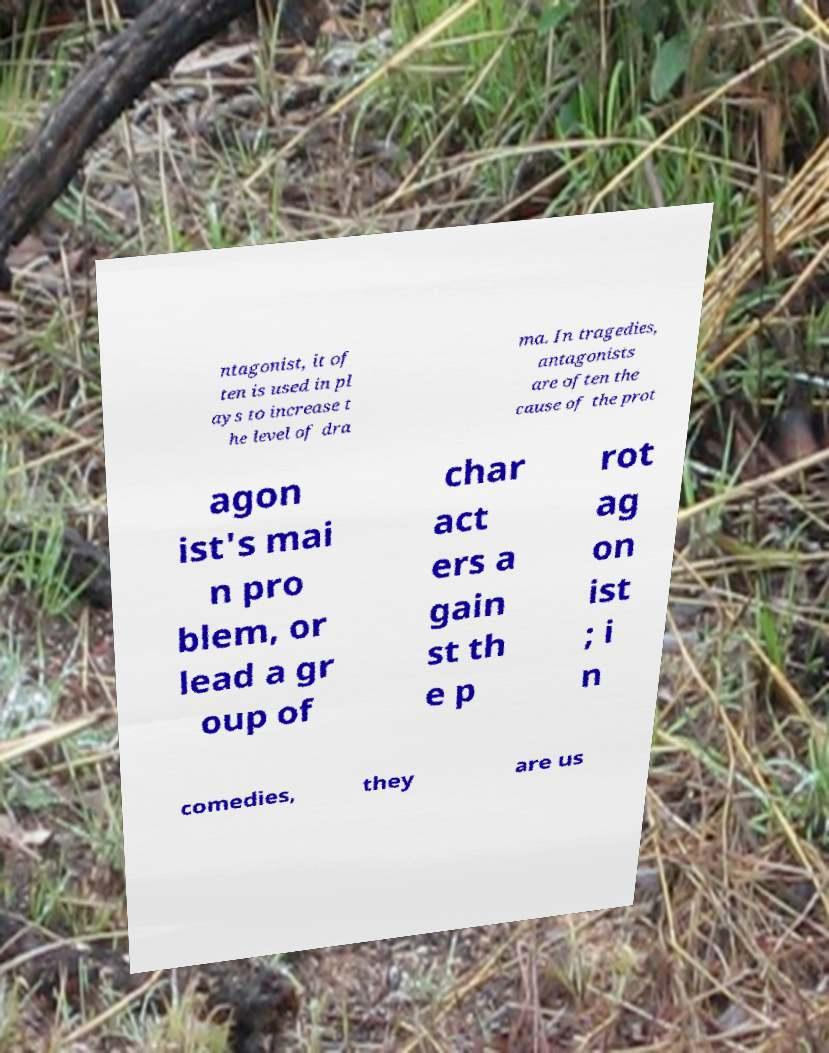Can you read and provide the text displayed in the image?This photo seems to have some interesting text. Can you extract and type it out for me? ntagonist, it of ten is used in pl ays to increase t he level of dra ma. In tragedies, antagonists are often the cause of the prot agon ist's mai n pro blem, or lead a gr oup of char act ers a gain st th e p rot ag on ist ; i n comedies, they are us 